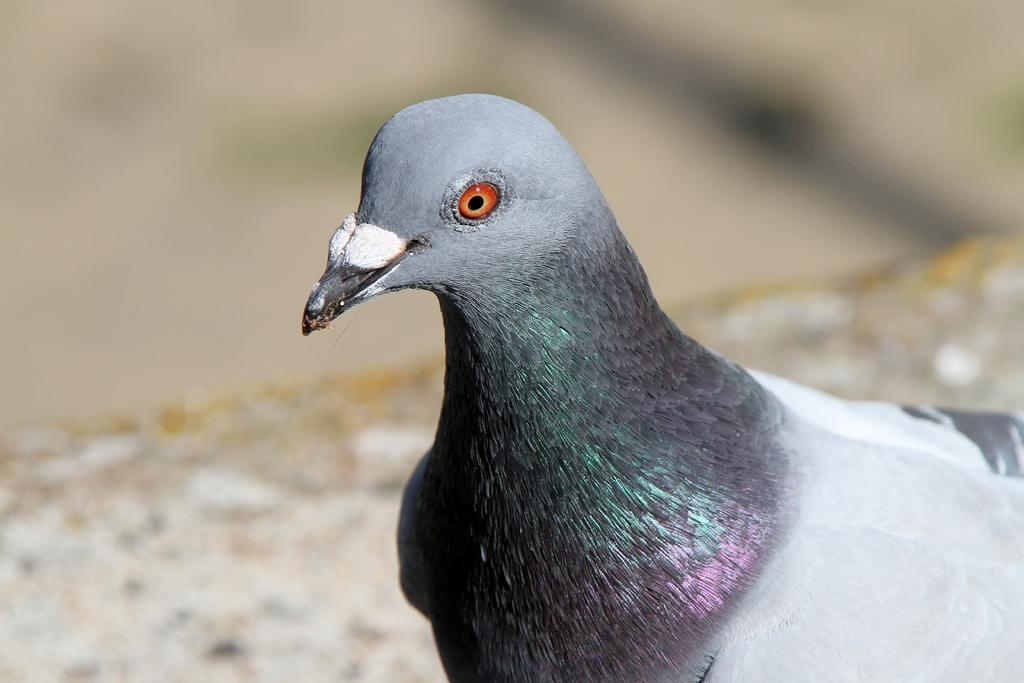What type of animal is in the image? There is a pigeon in the image. What colors can be seen on the pigeon? The pigeon has grey, white, black, green, and pink colors. How is the pigeon positioned in the image? The pigeon is blurred in the background. What type of tool is the carpenter using to fix the birdhouse in the image? There is no carpenter or birdhouse present in the image; it only features a pigeon. 